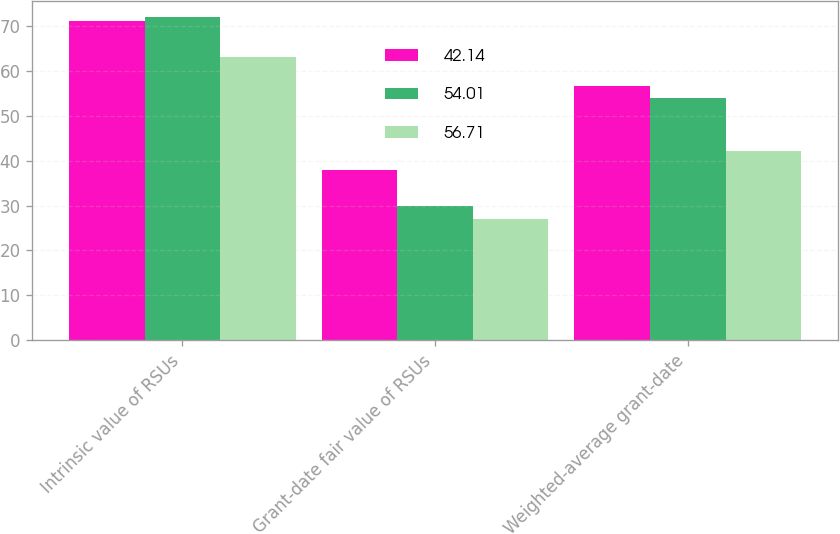Convert chart. <chart><loc_0><loc_0><loc_500><loc_500><stacked_bar_chart><ecel><fcel>Intrinsic value of RSUs<fcel>Grant-date fair value of RSUs<fcel>Weighted-average grant-date<nl><fcel>42.14<fcel>71<fcel>38<fcel>56.71<nl><fcel>54.01<fcel>72<fcel>30<fcel>54.01<nl><fcel>56.71<fcel>63<fcel>27<fcel>42.14<nl></chart> 